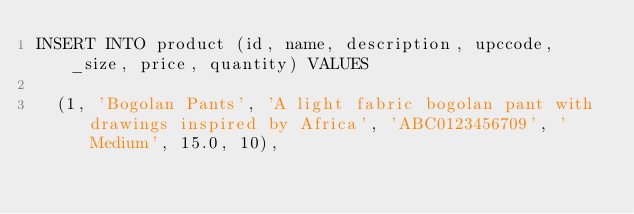<code> <loc_0><loc_0><loc_500><loc_500><_SQL_>INSERT INTO product (id, name, description, upccode, _size, price, quantity) VALUES
 
  (1, 'Bogolan Pants', 'A light fabric bogolan pant with drawings inspired by Africa', 'ABC0123456709', 'Medium', 15.0, 10),</code> 